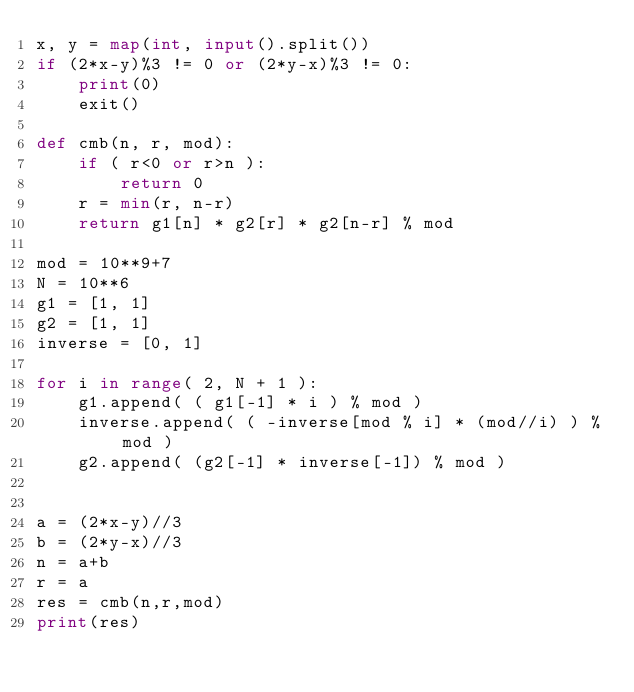Convert code to text. <code><loc_0><loc_0><loc_500><loc_500><_Python_>x, y = map(int, input().split())
if (2*x-y)%3 != 0 or (2*y-x)%3 != 0:
    print(0)
    exit()

def cmb(n, r, mod):
    if ( r<0 or r>n ):
        return 0
    r = min(r, n-r)
    return g1[n] * g2[r] * g2[n-r] % mod

mod = 10**9+7
N = 10**6
g1 = [1, 1]
g2 = [1, 1]
inverse = [0, 1]

for i in range( 2, N + 1 ):
    g1.append( ( g1[-1] * i ) % mod )
    inverse.append( ( -inverse[mod % i] * (mod//i) ) % mod )
    g2.append( (g2[-1] * inverse[-1]) % mod )


a = (2*x-y)//3
b = (2*y-x)//3
n = a+b
r = a
res = cmb(n,r,mod)
print(res)
</code> 